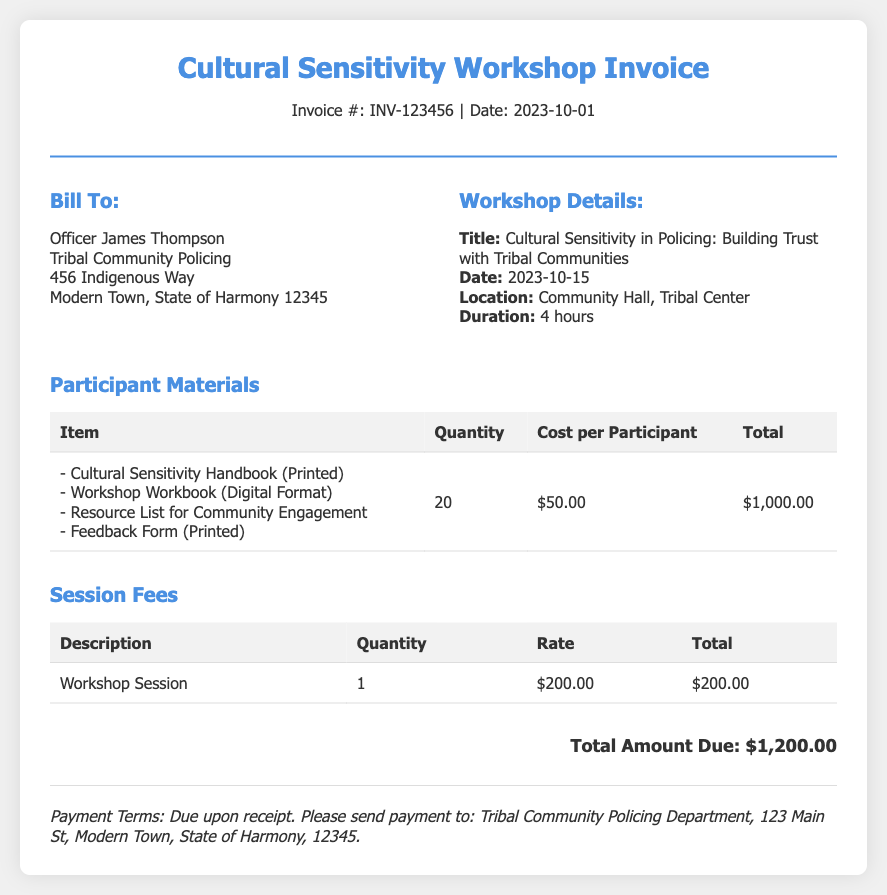What is the invoice number? The invoice number is listed at the top of the document.
Answer: INV-123456 What is the date of the workshop? The date of the workshop is provided in the workshop details section.
Answer: 2023-10-15 Who is the invoice billed to? The billing section contains the name of the recipient.
Answer: Officer James Thompson What is the total cost for participant materials? The total cost for participant materials is given in the materials section of the document.
Answer: $1,000.00 What is the rate for the workshop session? The rate is specified in the session fees table within the document.
Answer: $200.00 How many items are included in the participant materials? The table for participant materials indicates the number of items listed.
Answer: 4 What is the total amount due? The total amount due is stated at the bottom of the document.
Answer: $1,200.00 What type of document is this? The title of the document provides information about its nature.
Answer: Invoice What are the payment terms stated in the document? The payment terms are mentioned in the payment terms section of the document.
Answer: Due upon receipt 